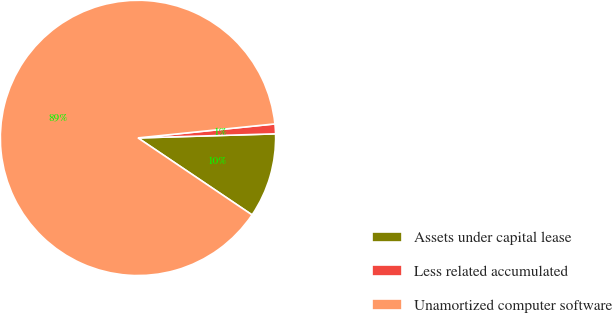Convert chart to OTSL. <chart><loc_0><loc_0><loc_500><loc_500><pie_chart><fcel>Assets under capital lease<fcel>Less related accumulated<fcel>Unamortized computer software<nl><fcel>9.92%<fcel>1.15%<fcel>88.93%<nl></chart> 